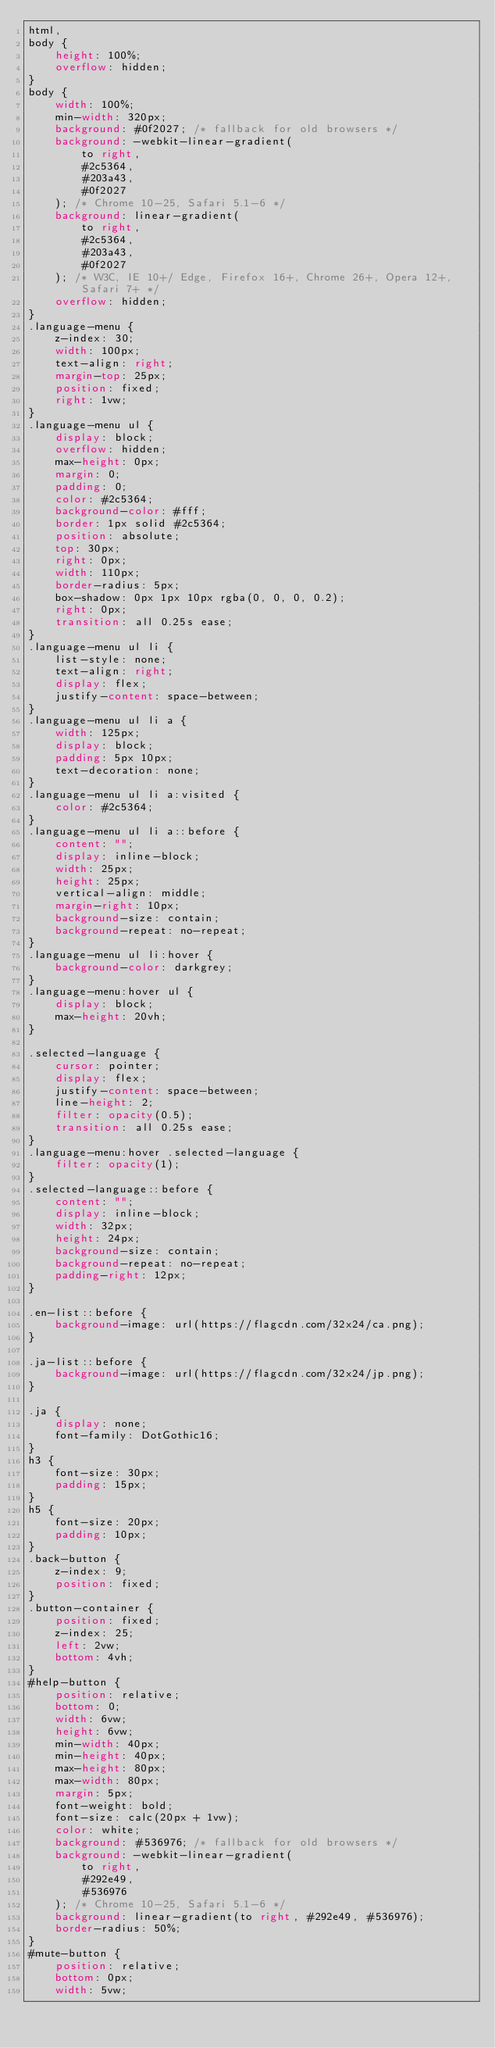<code> <loc_0><loc_0><loc_500><loc_500><_CSS_>html,
body {
    height: 100%;
    overflow: hidden;
}
body {
    width: 100%;
    min-width: 320px;
    background: #0f2027; /* fallback for old browsers */
    background: -webkit-linear-gradient(
        to right,
        #2c5364,
        #203a43,
        #0f2027
    ); /* Chrome 10-25, Safari 5.1-6 */
    background: linear-gradient(
        to right,
        #2c5364,
        #203a43,
        #0f2027
    ); /* W3C, IE 10+/ Edge, Firefox 16+, Chrome 26+, Opera 12+, Safari 7+ */
    overflow: hidden;
}
.language-menu {
    z-index: 30;
    width: 100px;
    text-align: right;
    margin-top: 25px;
    position: fixed;
    right: 1vw;
}
.language-menu ul {
    display: block;
    overflow: hidden;
    max-height: 0px;
    margin: 0;
    padding: 0;
    color: #2c5364;
    background-color: #fff;
    border: 1px solid #2c5364;
    position: absolute;
    top: 30px;
    right: 0px;
    width: 110px;
    border-radius: 5px;
    box-shadow: 0px 1px 10px rgba(0, 0, 0, 0.2);
    right: 0px;
    transition: all 0.25s ease;
}
.language-menu ul li {
    list-style: none;
    text-align: right;
    display: flex;
    justify-content: space-between;
}
.language-menu ul li a {
    width: 125px;
    display: block;
    padding: 5px 10px;
    text-decoration: none;
}
.language-menu ul li a:visited {
    color: #2c5364;
}
.language-menu ul li a::before {
    content: "";
    display: inline-block;
    width: 25px;
    height: 25px;
    vertical-align: middle;
    margin-right: 10px;
    background-size: contain;
    background-repeat: no-repeat;
}
.language-menu ul li:hover {
    background-color: darkgrey;
}
.language-menu:hover ul {
    display: block;
    max-height: 20vh;
}

.selected-language {
    cursor: pointer;
    display: flex;
    justify-content: space-between;
    line-height: 2;
    filter: opacity(0.5);
    transition: all 0.25s ease;
}
.language-menu:hover .selected-language {
    filter: opacity(1);
}
.selected-language::before {
    content: "";
    display: inline-block;
    width: 32px;
    height: 24px;
    background-size: contain;
    background-repeat: no-repeat;
    padding-right: 12px;
}

.en-list::before {
    background-image: url(https://flagcdn.com/32x24/ca.png);
}

.ja-list::before {
    background-image: url(https://flagcdn.com/32x24/jp.png);
}

.ja {
    display: none;
    font-family: DotGothic16;
}
h3 {
    font-size: 30px;
    padding: 15px;
}
h5 {
    font-size: 20px;
    padding: 10px;
}
.back-button {
    z-index: 9;
    position: fixed;
}
.button-container {
    position: fixed;
    z-index: 25;
    left: 2vw;
    bottom: 4vh;
}
#help-button {
    position: relative;
    bottom: 0;
    width: 6vw;
    height: 6vw;
    min-width: 40px;
    min-height: 40px;
    max-height: 80px;
    max-width: 80px;
    margin: 5px;
    font-weight: bold;
    font-size: calc(20px + 1vw);
    color: white;
    background: #536976; /* fallback for old browsers */
    background: -webkit-linear-gradient(
        to right,
        #292e49,
        #536976
    ); /* Chrome 10-25, Safari 5.1-6 */
    background: linear-gradient(to right, #292e49, #536976);
    border-radius: 50%;
}
#mute-button {
    position: relative;
    bottom: 0px;
    width: 5vw;</code> 